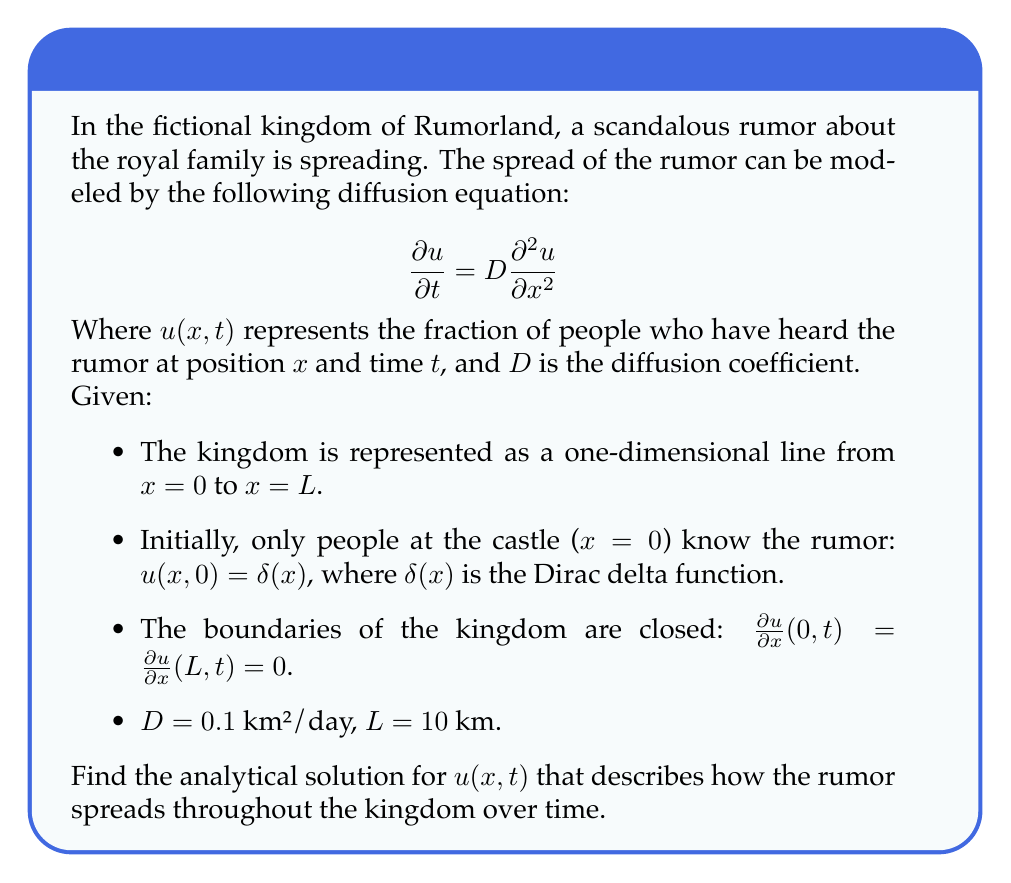Can you answer this question? To solve this diffusion equation, we'll follow these steps:

1) First, we need to recognize that this is a heat equation with Neumann boundary conditions. The general solution for such a problem is given by:

   $$u(x,t) = \frac{1}{L} + \sum_{n=1}^{\infty} A_n \cos(\frac{n\pi x}{L}) e^{-D(\frac{n\pi}{L})^2 t}$$

2) The coefficients $A_n$ are determined by the initial condition. In this case, we have a Dirac delta function at $x=0$, which can be expanded as:

   $$\delta(x) = \frac{1}{L} + \frac{2}{L}\sum_{n=1}^{\infty} \cos(\frac{n\pi x}{L})$$

3) Comparing this with our general solution at $t=0$, we can see that:

   $A_n = \frac{2}{L}$ for all $n$

4) Substituting this back into our general solution:

   $$u(x,t) = \frac{1}{L} + \frac{2}{L}\sum_{n=1}^{\infty} \cos(\frac{n\pi x}{L}) e^{-D(\frac{n\pi}{L})^2 t}$$

5) Now, let's substitute the given values: $D = 0.1$ km²/day, $L = 10$ km:

   $$u(x,t) = \frac{1}{10} + \frac{2}{10}\sum_{n=1}^{\infty} \cos(\frac{n\pi x}{10}) e^{-0.1(\frac{n\pi}{10})^2 t}$$

This is the analytical solution describing how the rumor spreads throughout the kingdom over time.
Answer: $$u(x,t) = \frac{1}{10} + \frac{1}{5}\sum_{n=1}^{\infty} \cos(\frac{n\pi x}{10}) e^{-0.001n^2\pi^2 t}$$ 